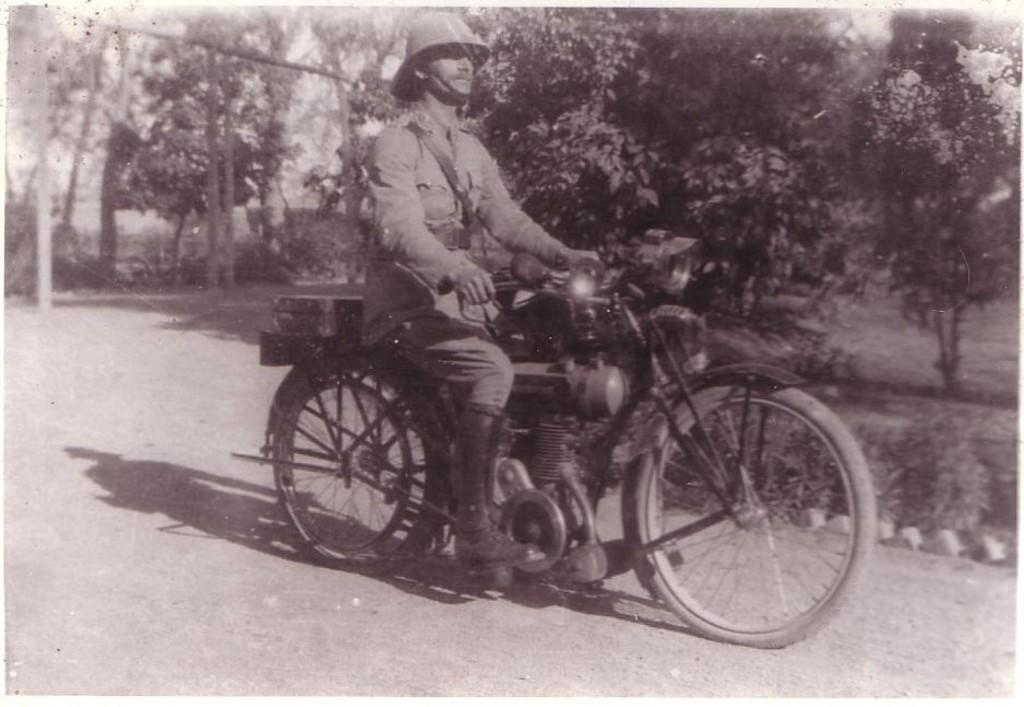What is the man in the image doing? The man is riding a motorbike in the image. What can be seen in the background of the image? There are trees in the background of the image. What protective gear is the man wearing? The man is wearing a helmet and boots. What type of gun is the man holding in the image? There is no gun present in the image; the man is riding a motorbike and wearing a helmet and boots. What fact can be learned about the stove in the image? There is no stove present in the image, so no facts about a stove can be learned. 